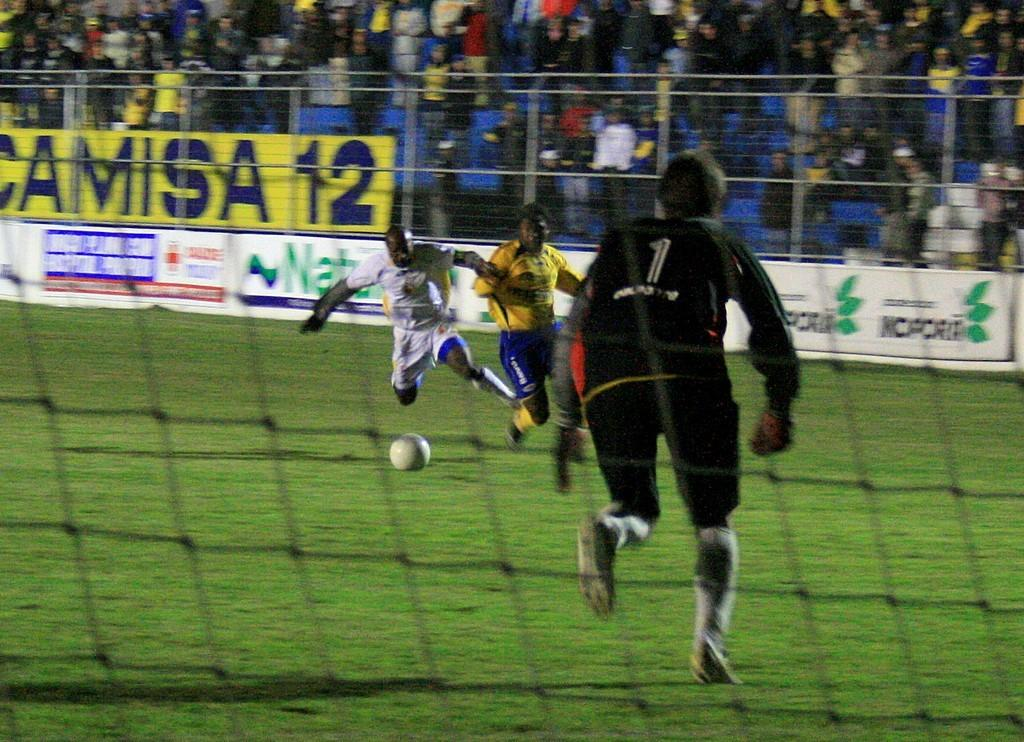<image>
Render a clear and concise summary of the photo. A soccer game is underway with a full stadium of fans cheering behind a yellow sign that says Camisa 12. 